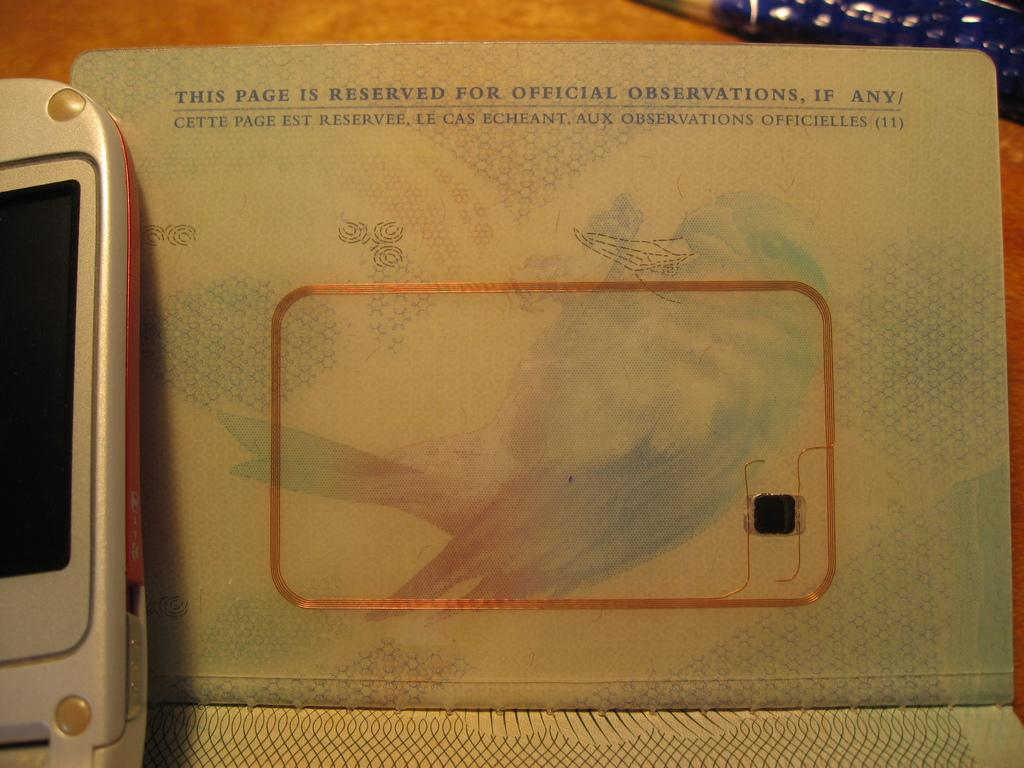<image>
Create a compact narrative representing the image presented. a page of a book that is reserved for official observations, if any 